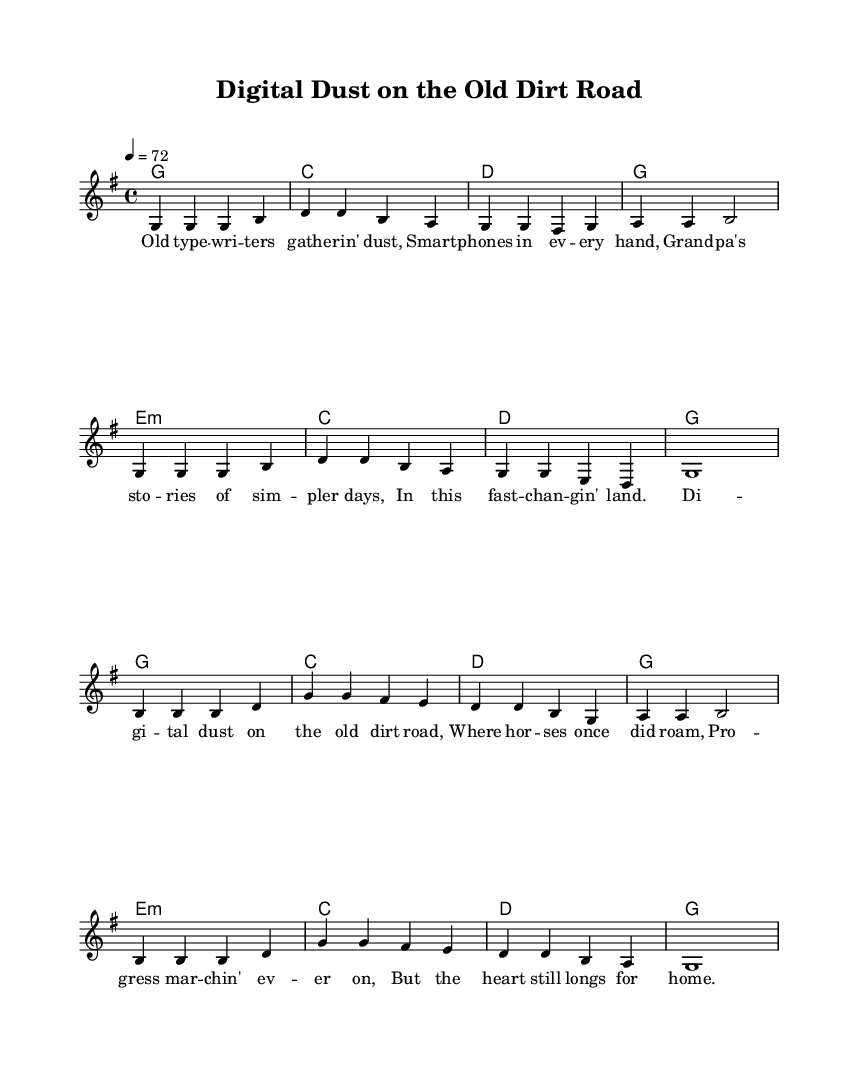what is the key signature of this music? The key signature is G major, which has one sharp (F#). This is indicated at the beginning of the score.
Answer: G major what is the time signature of this music? The time signature is 4/4, denoting four beats per measure. It can be found at the beginning of the score.
Answer: 4/4 what is the tempo marking of this music? The tempo marking is 72 beats per minute, stated at the beginning of the score. This indicates how fast the music should be played.
Answer: 72 how many measures are in the verse section? The verse section consists of eight measures, which can be counted directly from the staff lines containing the melody.
Answer: 8 what is the main theme reflected in the chorus? The main theme reflected in the chorus is nostalgia for simpler times amidst technological progress. This is derived from the lyrics and overall mood of the music.
Answer: Nostalgia which chord is used in the first measure of the verse? The chord used in the first measure of the verse is G major, as indicated by the chord symbols above the melody.
Answer: G how does the chorus contrast with the verse in terms of lyrical content? The chorus contrasts with the verse by expressing longing for the past and a connection to home, which differs from the verse's reflection on technological changes. This thematic shift is key to understanding the emotional undercurrent of the song.
Answer: Longing for home 